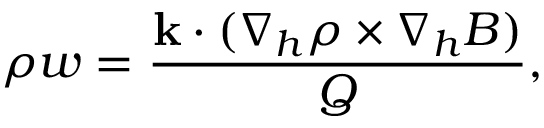Convert formula to latex. <formula><loc_0><loc_0><loc_500><loc_500>\rho w = \frac { { k } \cdot ( \nabla _ { h } \rho \times \nabla _ { h } B ) } { Q } ,</formula> 